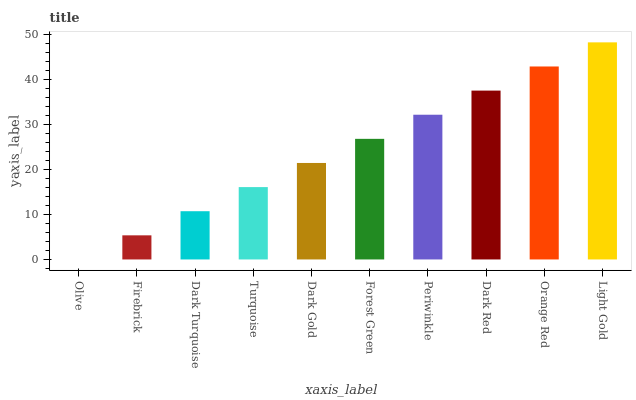Is Olive the minimum?
Answer yes or no. Yes. Is Light Gold the maximum?
Answer yes or no. Yes. Is Firebrick the minimum?
Answer yes or no. No. Is Firebrick the maximum?
Answer yes or no. No. Is Firebrick greater than Olive?
Answer yes or no. Yes. Is Olive less than Firebrick?
Answer yes or no. Yes. Is Olive greater than Firebrick?
Answer yes or no. No. Is Firebrick less than Olive?
Answer yes or no. No. Is Forest Green the high median?
Answer yes or no. Yes. Is Dark Gold the low median?
Answer yes or no. Yes. Is Dark Red the high median?
Answer yes or no. No. Is Turquoise the low median?
Answer yes or no. No. 